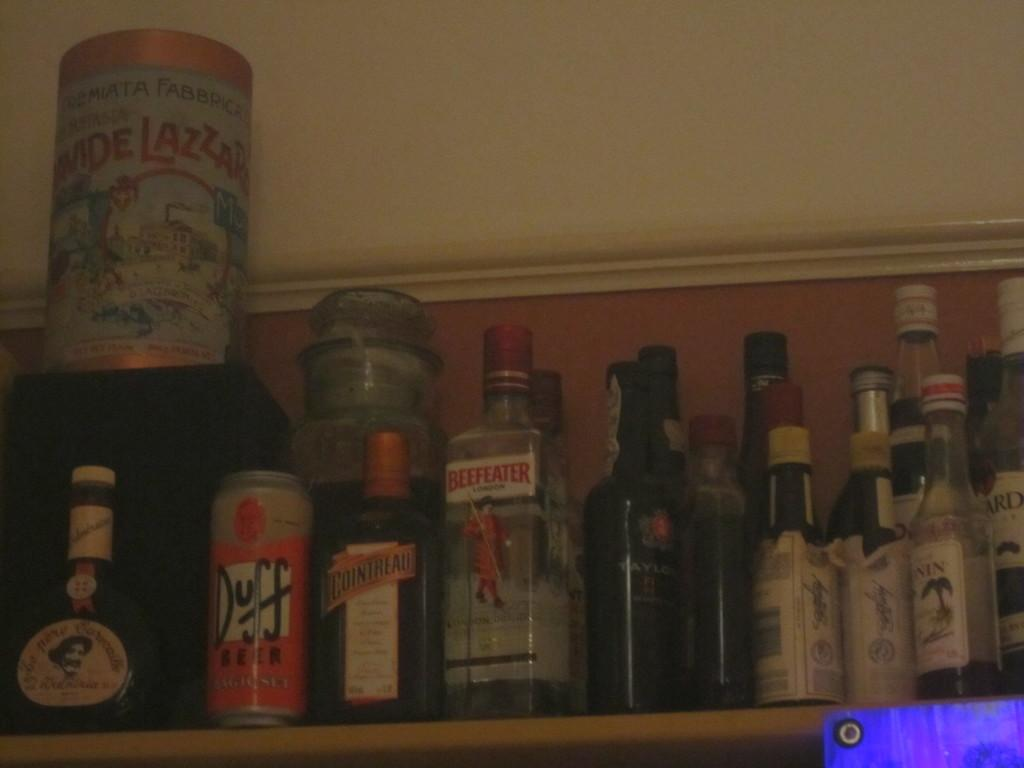Provide a one-sentence caption for the provided image. Various items on a shelf including a can of Duff beer. 